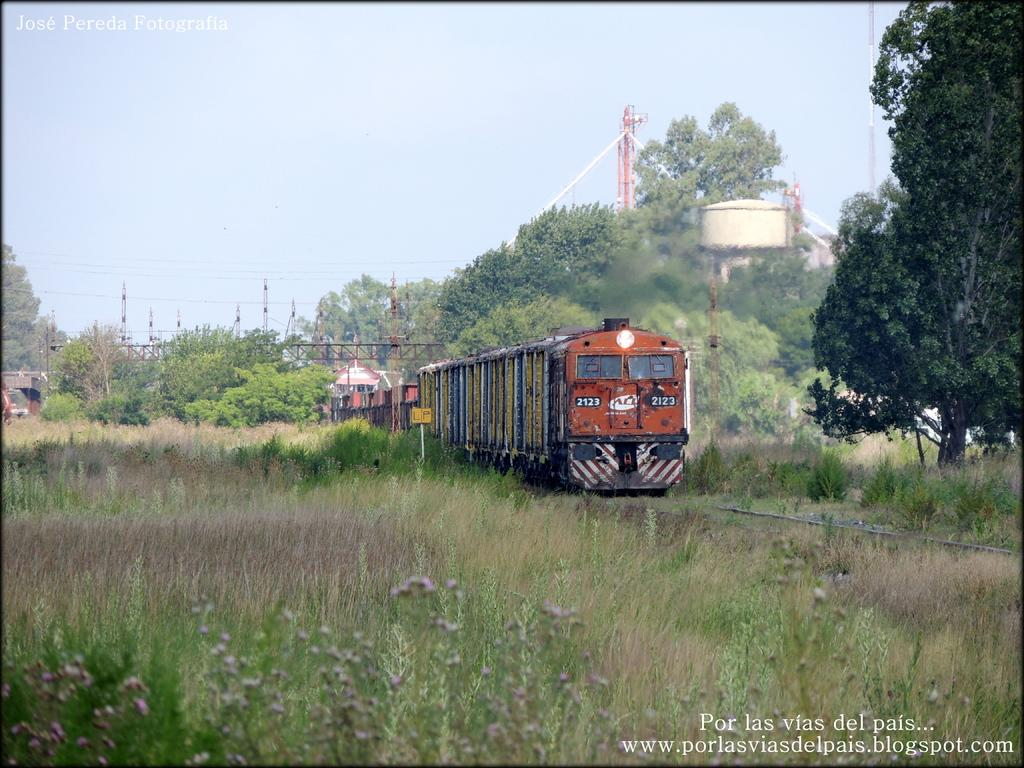Provide a one-sentence caption for the provided image. A train with the number 2123 heading down an overgrown track. 